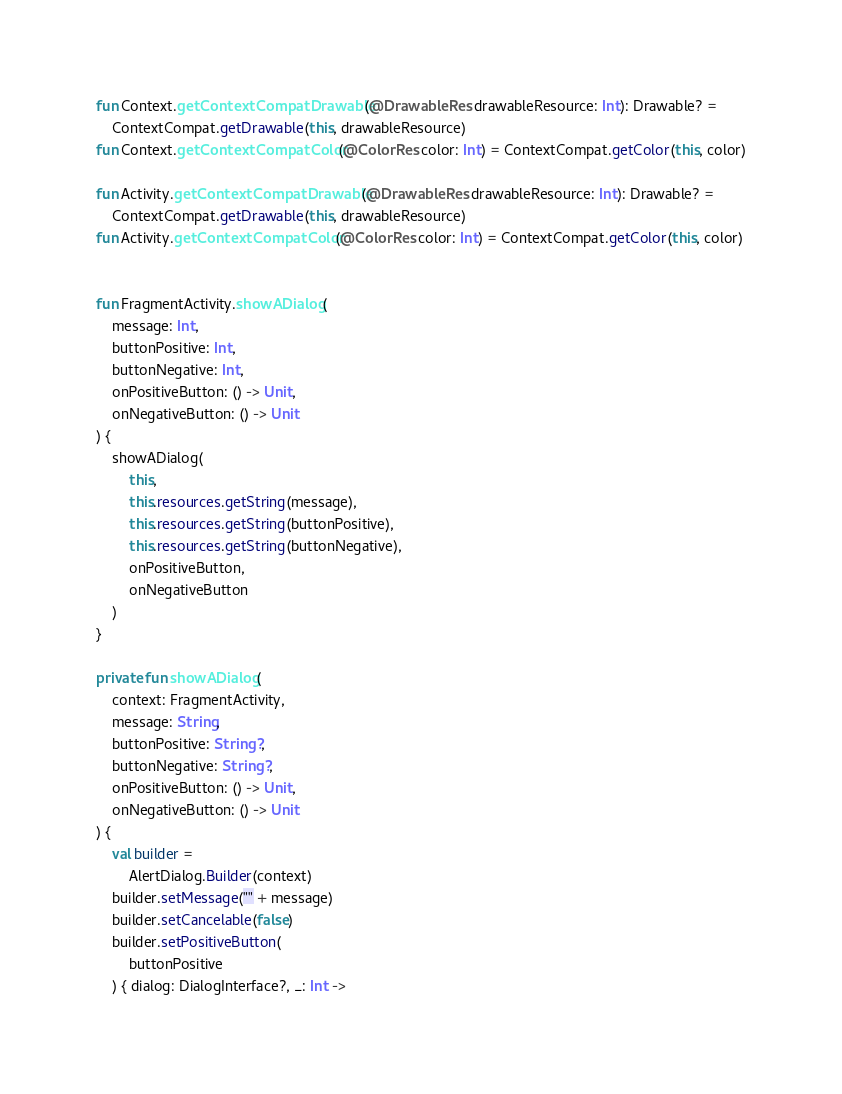<code> <loc_0><loc_0><loc_500><loc_500><_Kotlin_>

fun Context.getContextCompatDrawable(@DrawableRes drawableResource: Int): Drawable? =
    ContextCompat.getDrawable(this, drawableResource)
fun Context.getContextCompatColor(@ColorRes color: Int) = ContextCompat.getColor(this, color)

fun Activity.getContextCompatDrawable(@DrawableRes drawableResource: Int): Drawable? =
    ContextCompat.getDrawable(this, drawableResource)
fun Activity.getContextCompatColor(@ColorRes color: Int) = ContextCompat.getColor(this, color)


fun FragmentActivity.showADialog(
    message: Int,
    buttonPositive: Int,
    buttonNegative: Int,
    onPositiveButton: () -> Unit,
    onNegativeButton: () -> Unit
) {
    showADialog(
        this,
        this.resources.getString(message),
        this.resources.getString(buttonPositive),
        this.resources.getString(buttonNegative),
        onPositiveButton,
        onNegativeButton
    )
}

private fun showADialog(
    context: FragmentActivity,
    message: String,
    buttonPositive: String?,
    buttonNegative: String?,
    onPositiveButton: () -> Unit,
    onNegativeButton: () -> Unit
) {
    val builder =
        AlertDialog.Builder(context)
    builder.setMessage("" + message)
    builder.setCancelable(false)
    builder.setPositiveButton(
        buttonPositive
    ) { dialog: DialogInterface?, _: Int -></code> 